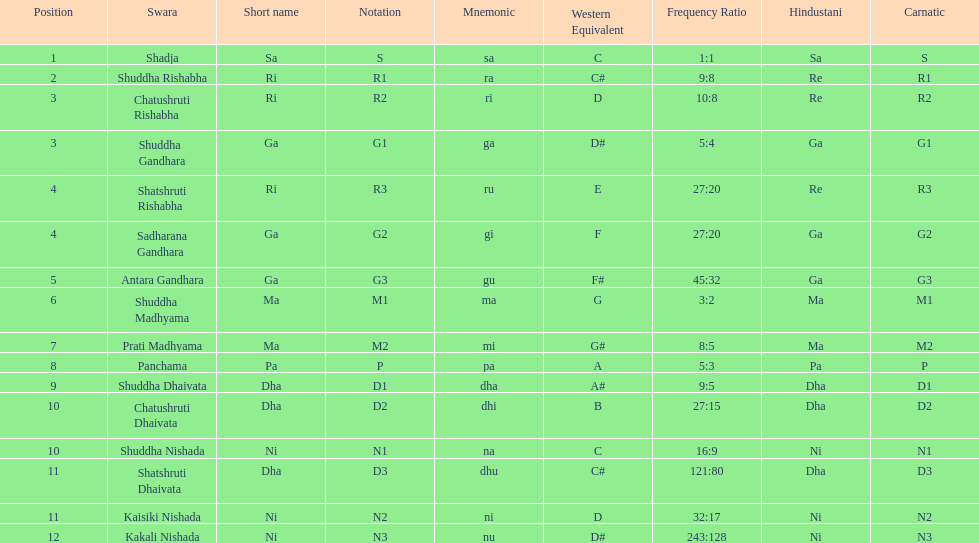Which swara follows immediately after antara gandhara? Shuddha Madhyama. Would you be able to parse every entry in this table? {'header': ['Position', 'Swara', 'Short name', 'Notation', 'Mnemonic', 'Western Equivalent', 'Frequency Ratio', 'Hindustani', 'Carnatic'], 'rows': [['1', 'Shadja', 'Sa', 'S', 'sa', 'C', '1:1', 'Sa', 'S'], ['2', 'Shuddha Rishabha', 'Ri', 'R1', 'ra', 'C#', '9:8', 'Re', 'R1'], ['3', 'Chatushruti Rishabha', 'Ri', 'R2', 'ri', 'D', '10:8', 'Re', 'R2'], ['3', 'Shuddha Gandhara', 'Ga', 'G1', 'ga', 'D#', '5:4', 'Ga', 'G1'], ['4', 'Shatshruti Rishabha', 'Ri', 'R3', 'ru', 'E', '27:20', 'Re', 'R3'], ['4', 'Sadharana Gandhara', 'Ga', 'G2', 'gi', 'F', '27:20', 'Ga', 'G2'], ['5', 'Antara Gandhara', 'Ga', 'G3', 'gu', 'F#', '45:32', 'Ga', 'G3'], ['6', 'Shuddha Madhyama', 'Ma', 'M1', 'ma', 'G', '3:2', 'Ma', 'M1'], ['7', 'Prati Madhyama', 'Ma', 'M2', 'mi', 'G#', '8:5', 'Ma', 'M2'], ['8', 'Panchama', 'Pa', 'P', 'pa', 'A', '5:3', 'Pa', 'P'], ['9', 'Shuddha Dhaivata', 'Dha', 'D1', 'dha', 'A#', '9:5', 'Dha', 'D1'], ['10', 'Chatushruti Dhaivata', 'Dha', 'D2', 'dhi', 'B', '27:15', 'Dha', 'D2'], ['10', 'Shuddha Nishada', 'Ni', 'N1', 'na', 'C', '16:9', 'Ni', 'N1'], ['11', 'Shatshruti Dhaivata', 'Dha', 'D3', 'dhu', 'C#', '121:80', 'Dha', 'D3'], ['11', 'Kaisiki Nishada', 'Ni', 'N2', 'ni', 'D', '32:17', 'Ni', 'N2'], ['12', 'Kakali Nishada', 'Ni', 'N3', 'nu', 'D#', '243:128', 'Ni', 'N3']]} 